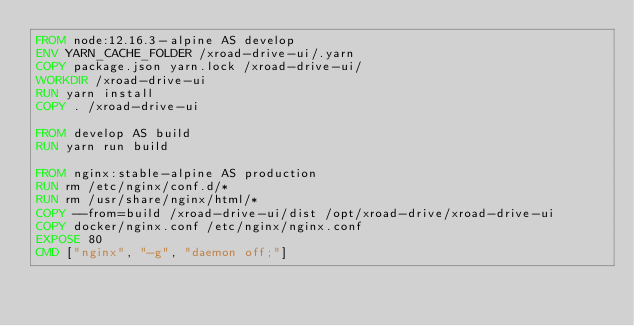<code> <loc_0><loc_0><loc_500><loc_500><_Dockerfile_>FROM node:12.16.3-alpine AS develop
ENV YARN_CACHE_FOLDER /xroad-drive-ui/.yarn
COPY package.json yarn.lock /xroad-drive-ui/
WORKDIR /xroad-drive-ui
RUN yarn install
COPY . /xroad-drive-ui

FROM develop AS build
RUN yarn run build

FROM nginx:stable-alpine AS production
RUN rm /etc/nginx/conf.d/*
RUN rm /usr/share/nginx/html/*
COPY --from=build /xroad-drive-ui/dist /opt/xroad-drive/xroad-drive-ui
COPY docker/nginx.conf /etc/nginx/nginx.conf
EXPOSE 80
CMD ["nginx", "-g", "daemon off;"]</code> 